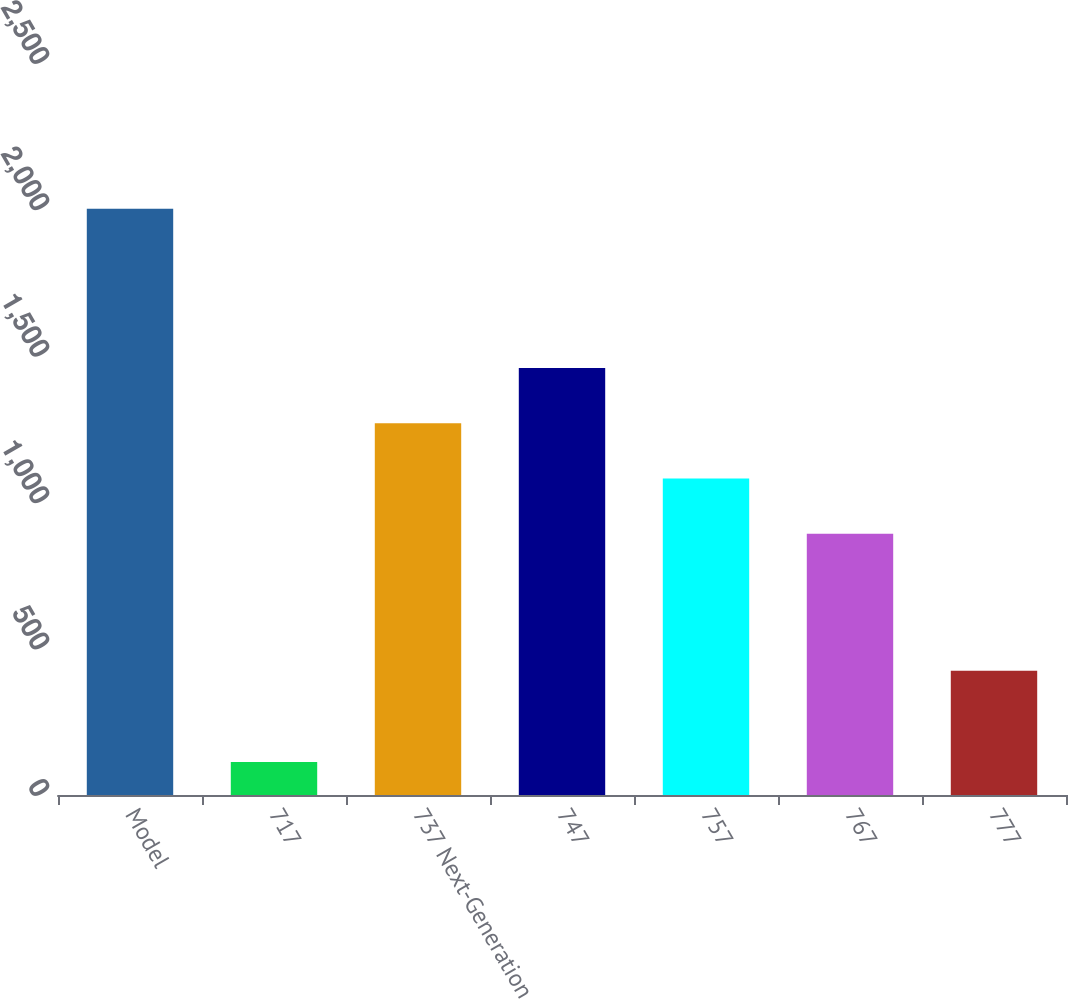<chart> <loc_0><loc_0><loc_500><loc_500><bar_chart><fcel>Model<fcel>717<fcel>737 Next-Generation<fcel>747<fcel>757<fcel>767<fcel>777<nl><fcel>2002<fcel>113<fcel>1269.8<fcel>1458.7<fcel>1080.9<fcel>892<fcel>424<nl></chart> 